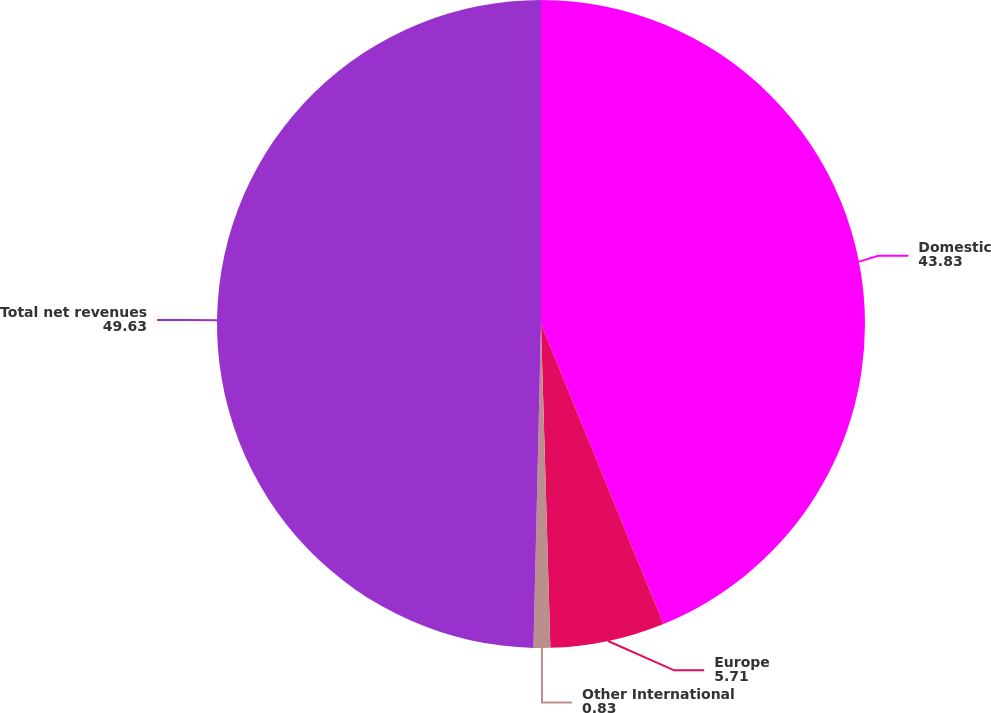<chart> <loc_0><loc_0><loc_500><loc_500><pie_chart><fcel>Domestic<fcel>Europe<fcel>Other International<fcel>Total net revenues<nl><fcel>43.83%<fcel>5.71%<fcel>0.83%<fcel>49.63%<nl></chart> 